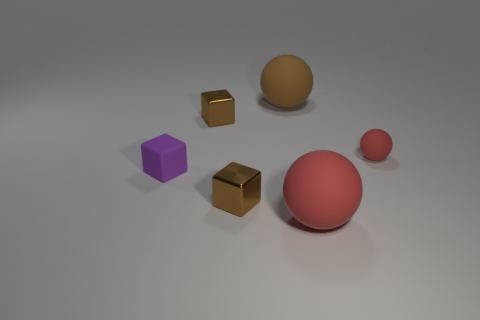How many other objects are the same shape as the big red thing?
Provide a short and direct response. 2. What is the color of the rubber thing that is both to the left of the large red object and in front of the small sphere?
Keep it short and to the point. Purple. What is the color of the tiny rubber sphere?
Make the answer very short. Red. Does the purple object have the same material as the red sphere that is on the left side of the small sphere?
Make the answer very short. Yes. There is a large brown object that is the same material as the purple cube; what shape is it?
Your response must be concise. Sphere. What color is the other matte ball that is the same size as the brown matte ball?
Your answer should be compact. Red. Does the ball that is in front of the purple matte thing have the same size as the brown matte thing?
Give a very brief answer. Yes. What number of purple matte objects are there?
Your response must be concise. 1. How many balls are big red things or tiny purple things?
Your answer should be compact. 1. How many large brown balls are right of the large rubber sphere behind the big red matte object?
Your response must be concise. 0. 